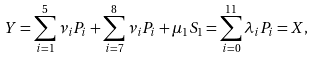Convert formula to latex. <formula><loc_0><loc_0><loc_500><loc_500>Y = \sum _ { i = 1 } ^ { 5 } \nu _ { i } P _ { i } + \sum _ { i = 7 } ^ { 8 } \nu _ { i } P _ { i } + \mu _ { 1 } S _ { 1 } = \sum _ { i = 0 } ^ { 1 1 } \lambda _ { i } P _ { i } = X ,</formula> 